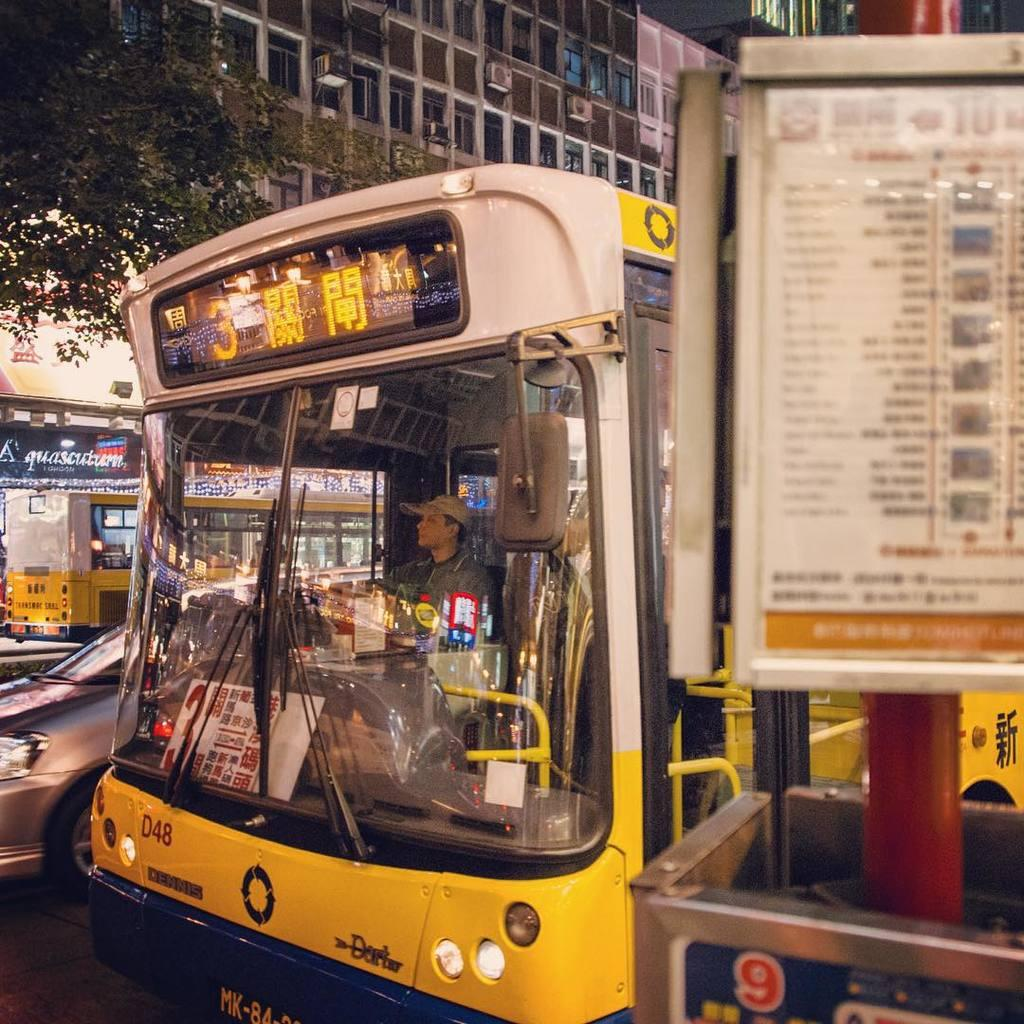<image>
Offer a succinct explanation of the picture presented. the number 3 on a bus that is outside 